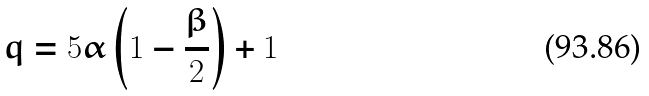<formula> <loc_0><loc_0><loc_500><loc_500>q = 5 \alpha \left ( 1 - \frac { \beta } { 2 } \right ) + 1</formula> 